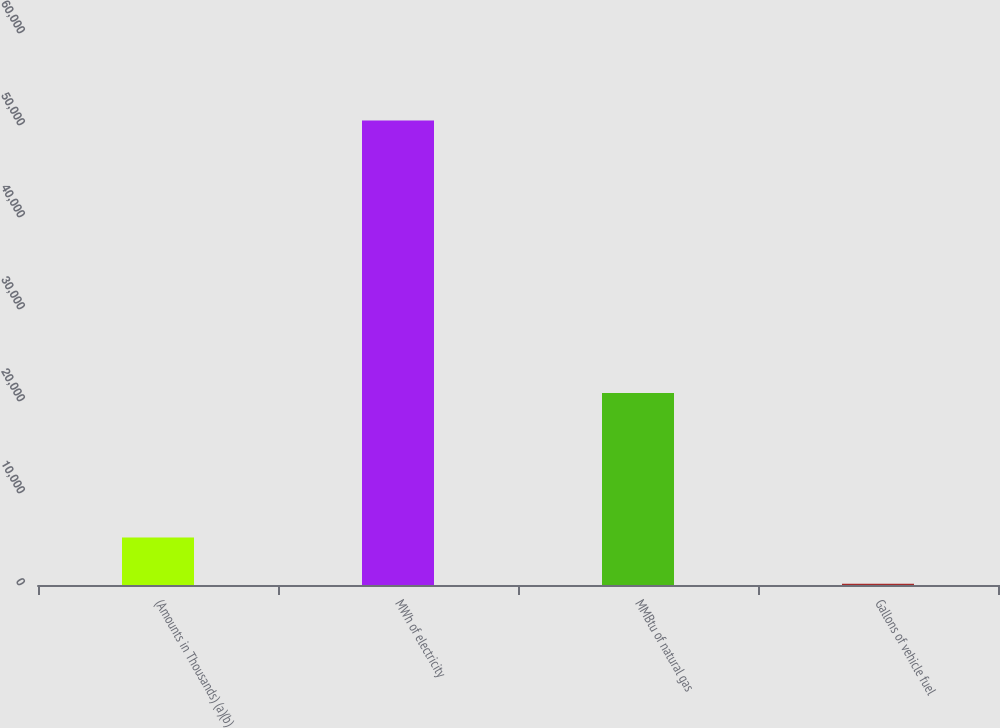Convert chart. <chart><loc_0><loc_0><loc_500><loc_500><bar_chart><fcel>(Amounts in Thousands) (a)(b)<fcel>MWh of electricity<fcel>MMBtu of natural gas<fcel>Gallons of vehicle fuel<nl><fcel>5175.6<fcel>50487<fcel>20874<fcel>141<nl></chart> 